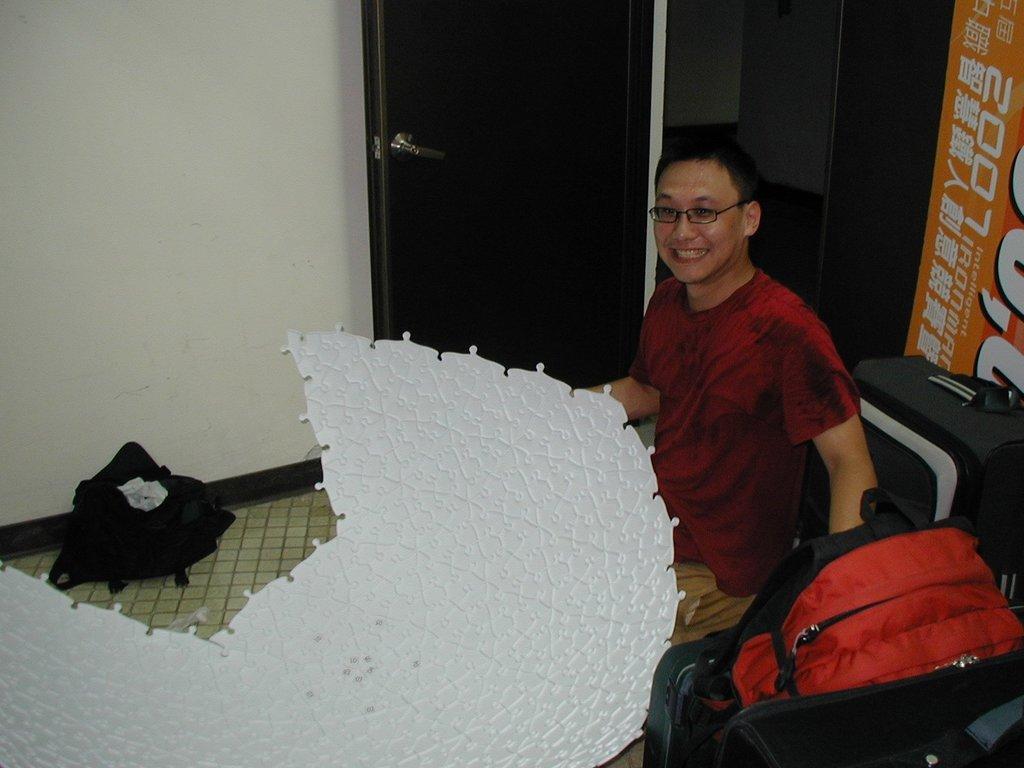Describe this image in one or two sentences. This image consists of a person. He is sitting. There are bags at the bottom. There is a door at the top. 